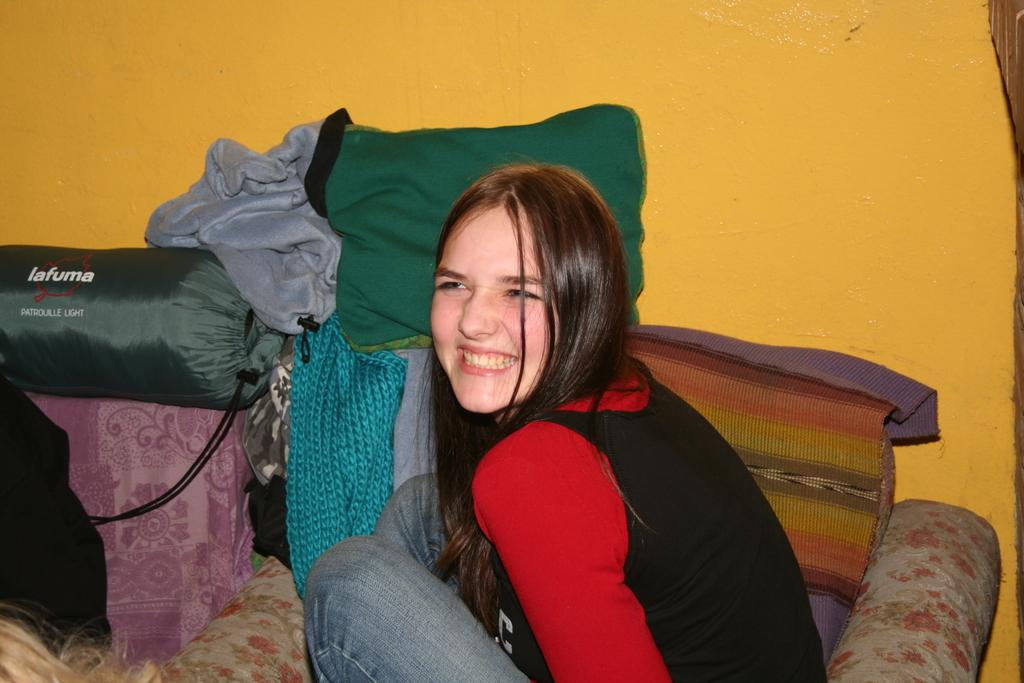What is the woman doing in the image? The woman is sitting on the sofa in the image. What can be seen on the sofa besides the woman? Cushions are present on the sofa in the image. What else is visible in the image that might provide comfort? Blankets are visible in the image. What color is the wall in the background of the image? The wall in the background of the image is orange. Where was the image taken? The image was taken in a room. What grade did the woman receive for her underwear in the image? There is no mention of underwear or grades in the image, so this question cannot be answered. 